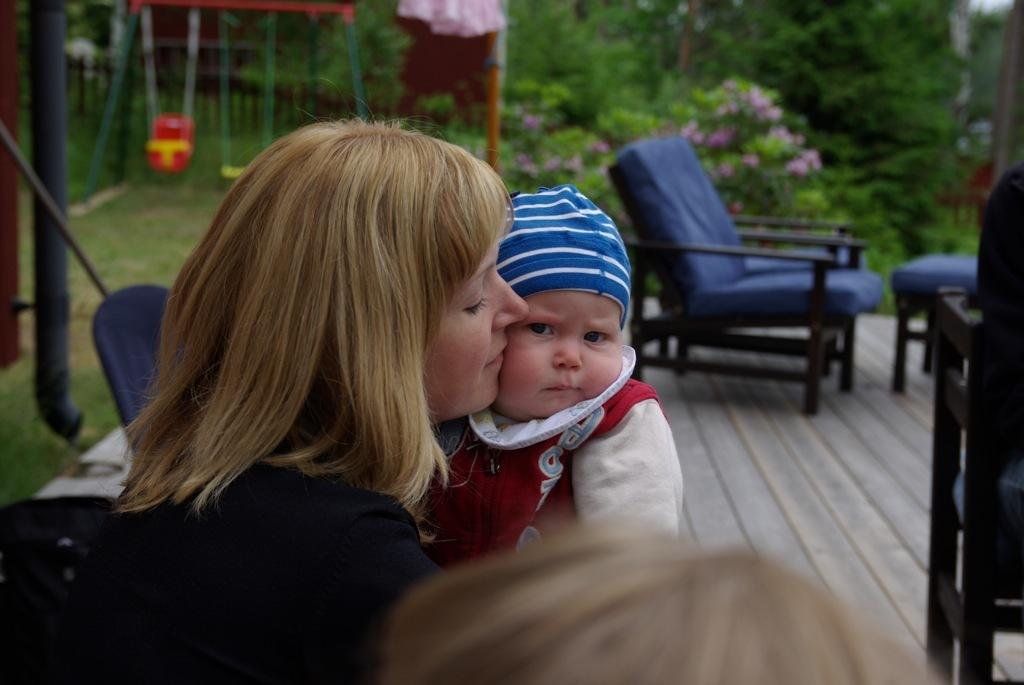Who is present in the image? There is a woman and a child in the image. What can be seen in the background of the image? There are chairs and trees in the background of the image. What letter is the child trying to kick in the image? There is no letter present in the image, and the child is not shown kicking anything. 